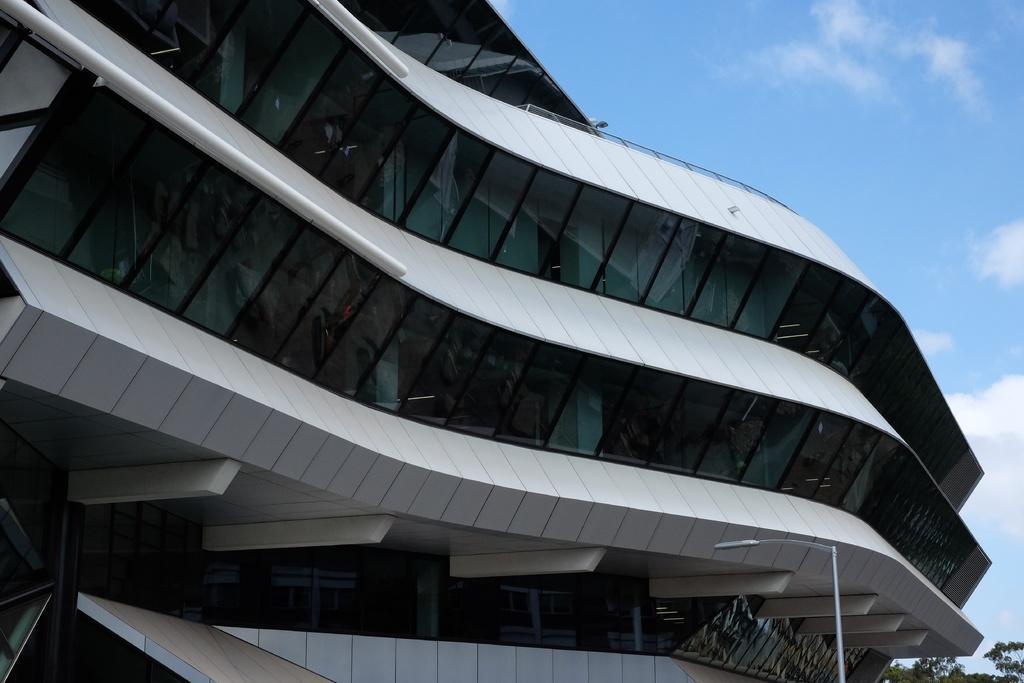Can you describe this image briefly? In this picture we can see a building, pole, trees and in the background we can see the sky with clouds. 